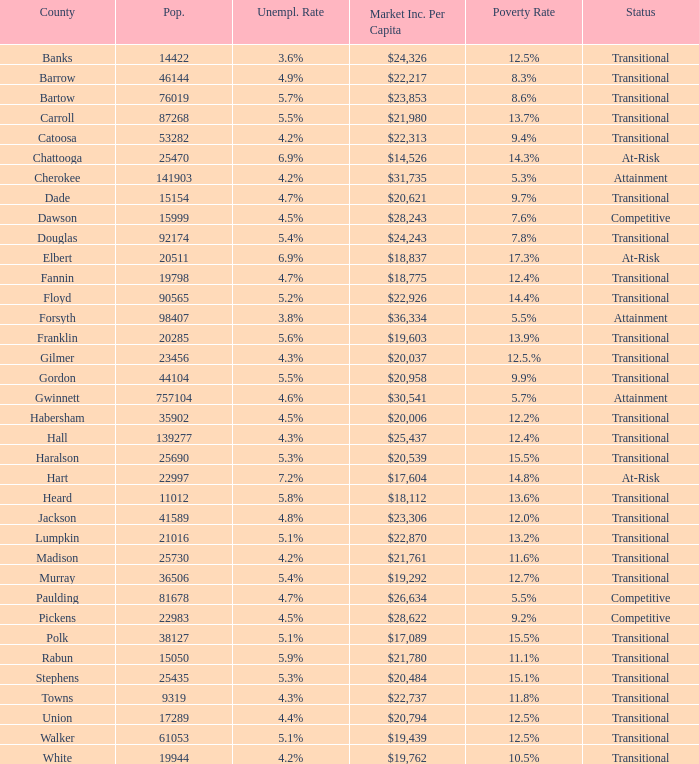6% joblessness rate? Banks. 